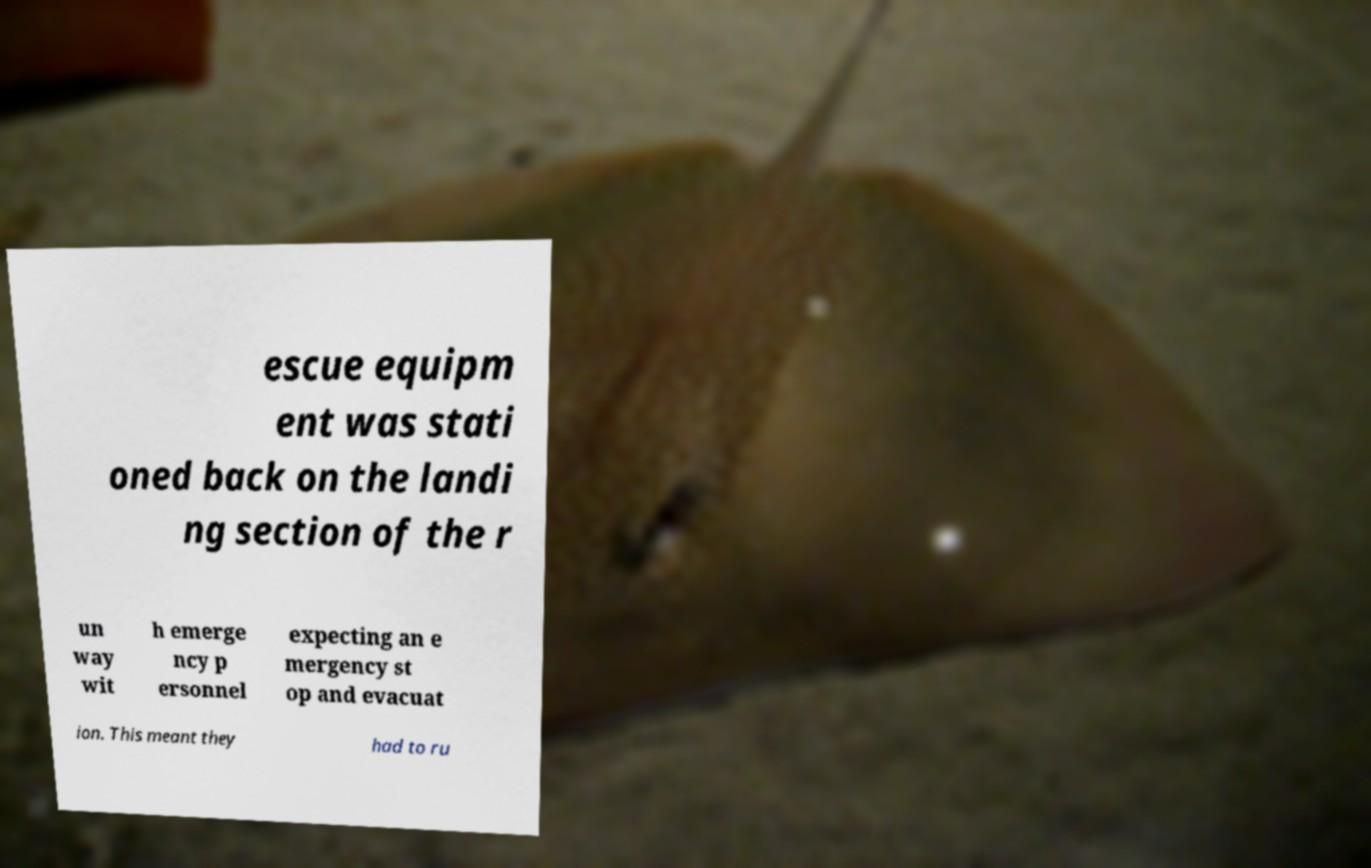Could you assist in decoding the text presented in this image and type it out clearly? escue equipm ent was stati oned back on the landi ng section of the r un way wit h emerge ncy p ersonnel expecting an e mergency st op and evacuat ion. This meant they had to ru 